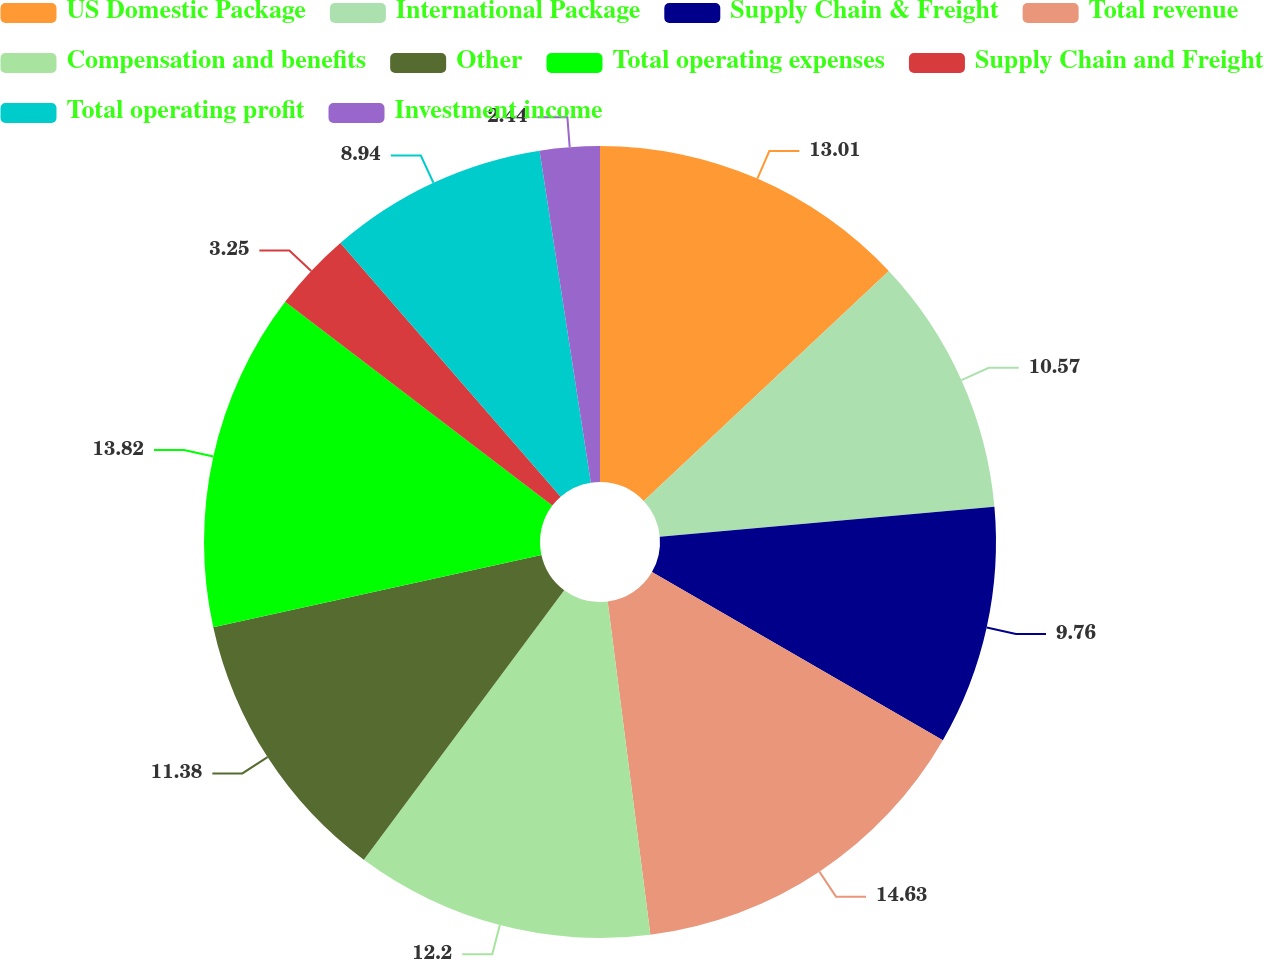Convert chart to OTSL. <chart><loc_0><loc_0><loc_500><loc_500><pie_chart><fcel>US Domestic Package<fcel>International Package<fcel>Supply Chain & Freight<fcel>Total revenue<fcel>Compensation and benefits<fcel>Other<fcel>Total operating expenses<fcel>Supply Chain and Freight<fcel>Total operating profit<fcel>Investment income<nl><fcel>13.01%<fcel>10.57%<fcel>9.76%<fcel>14.63%<fcel>12.2%<fcel>11.38%<fcel>13.82%<fcel>3.25%<fcel>8.94%<fcel>2.44%<nl></chart> 